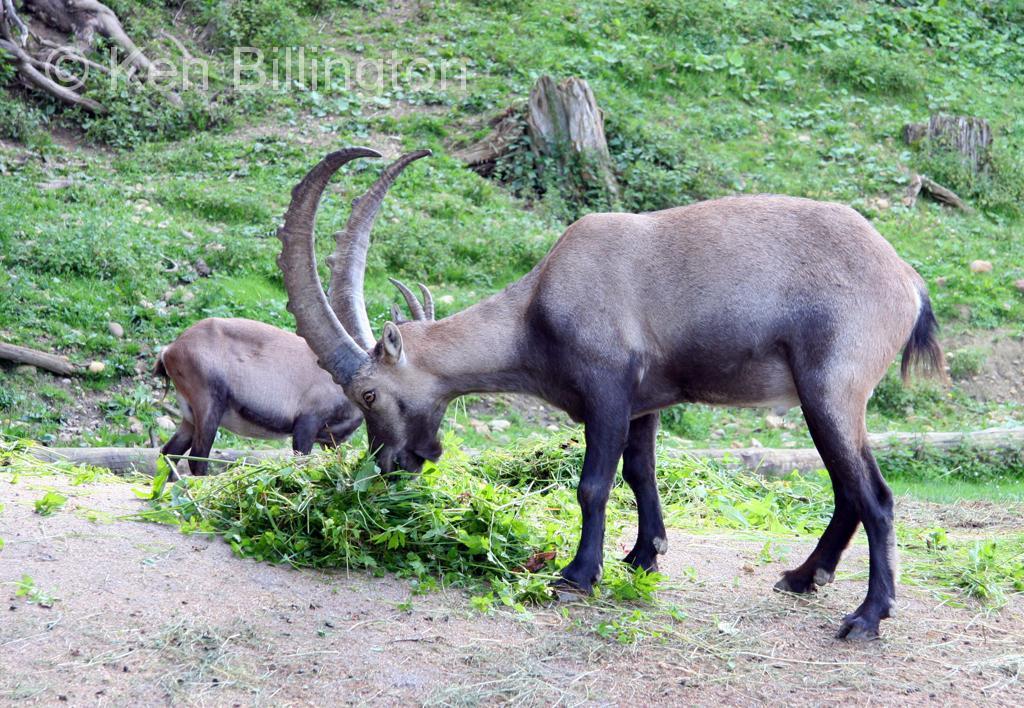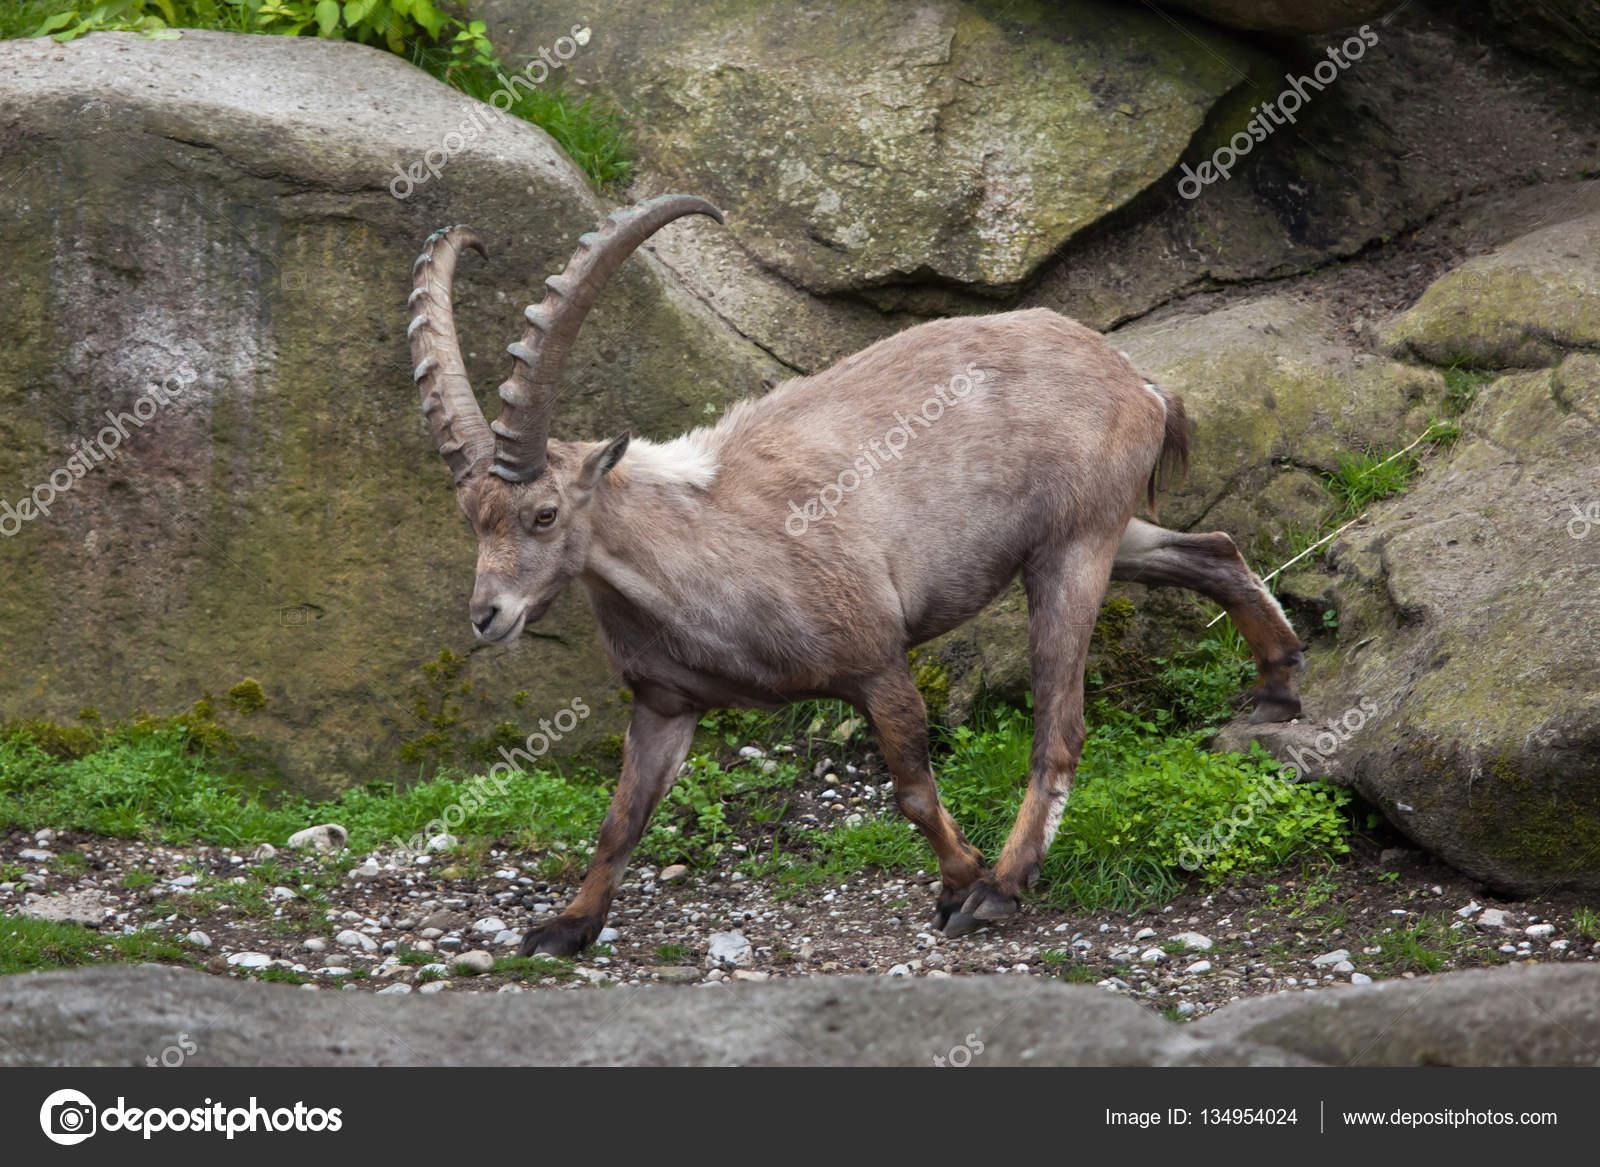The first image is the image on the left, the second image is the image on the right. Considering the images on both sides, is "There are only two goats visible." valid? Answer yes or no. No. The first image is the image on the left, the second image is the image on the right. Evaluate the accuracy of this statement regarding the images: "There are exactly two mountain goats.". Is it true? Answer yes or no. No. 